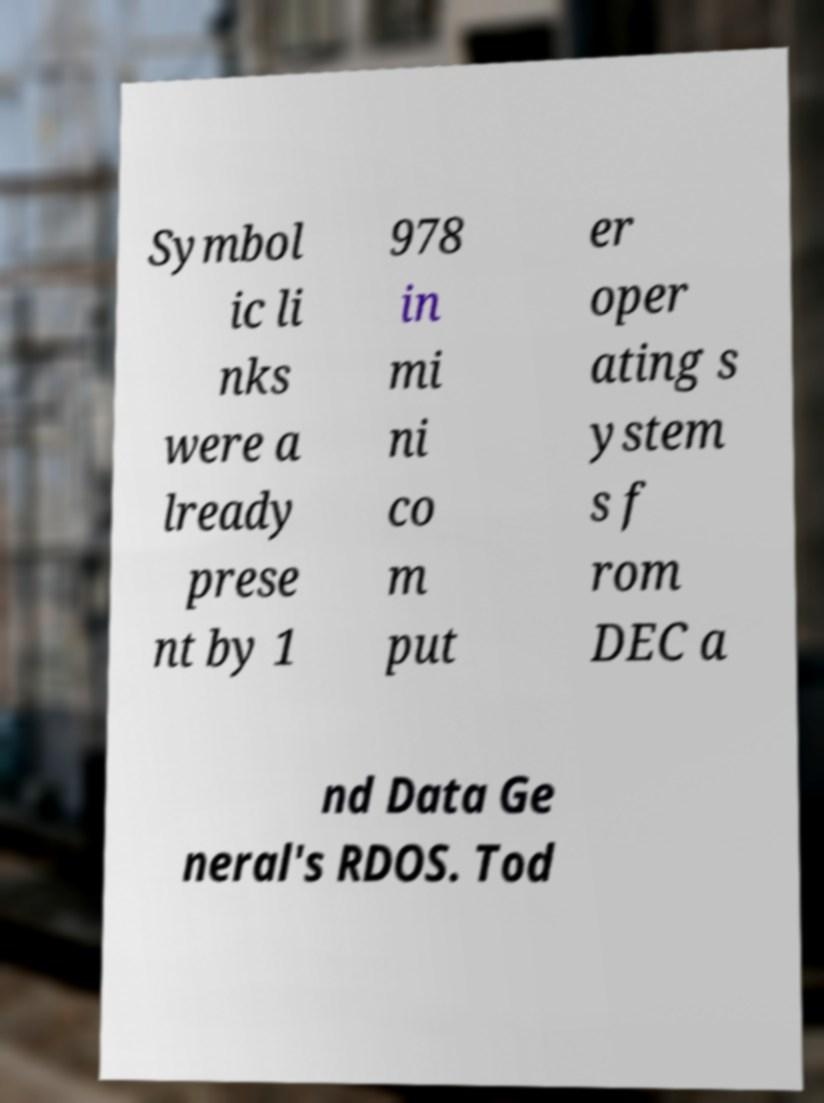Can you accurately transcribe the text from the provided image for me? Symbol ic li nks were a lready prese nt by 1 978 in mi ni co m put er oper ating s ystem s f rom DEC a nd Data Ge neral's RDOS. Tod 